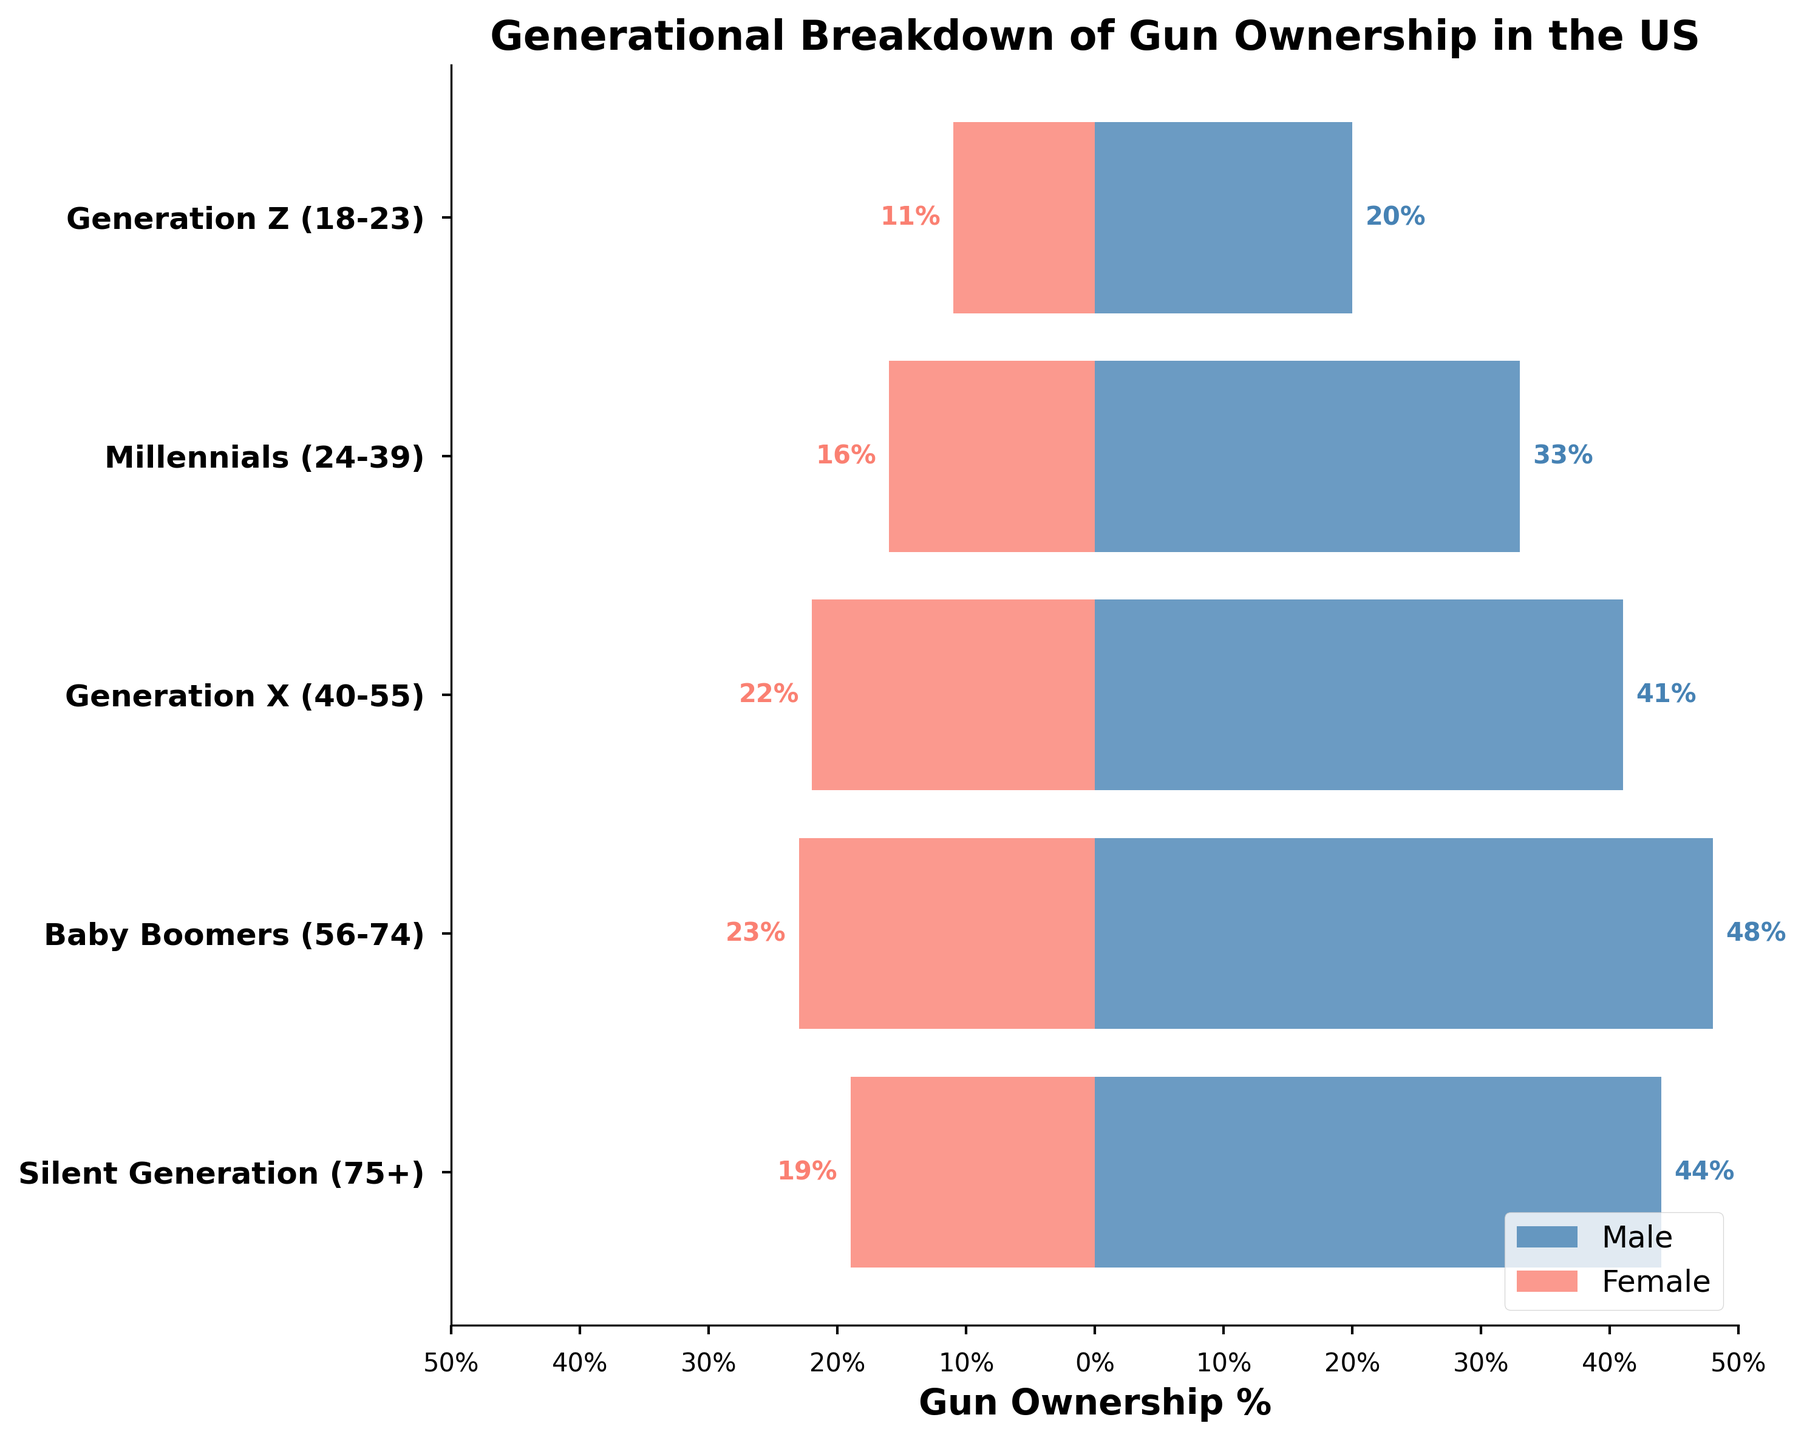What is the title of the figure? The title is located at the top of the figure and explicitly states the main topic being depicted.
Answer: Generational Breakdown of Gun Ownership in the US Which gender has the highest gun ownership percentage in the Baby Boomers group? By comparing the bar lengths in the Baby Boomers row, the bar representing males is longer than the bar representing females.
Answer: Male What is the percentage difference in gun ownership between males and females in the Silent Generation? The percentage difference is found by subtracting the female ownership percentage from the male ownership percentage for the Silent Generation: 44% - 19% = 25%.
Answer: 25% How does male gun ownership in Generation Z compare to female gun ownership in Generation X? Visual inspection shows that the bar for male ownership in Generation Z is 20%, while the bar for female ownership in Generation X is 22%. Thus, female ownership in Generation X is slightly higher.
Answer: Female ownership in Generation X is higher What age group shows the least disparity between male and female gun ownership percentages? By looking at the bars for each age group, the Millennium group has the closest percentages: 33% for males and 16% for females, a difference of 17 percentage points.
Answer: Millennials What is the average gun ownership percentage for males across all generations? The average is calculated by summing the percentages for males across all generations and then dividing by the number of generations: (44 + 48 + 41 + 33 + 20) / 5 = 37.2%.
Answer: 37.2% Which age group has the highest female gun ownership percentage? Comparing the lengths of the bars for females across all age groups, Baby Boomers have the highest percentage at 23%.
Answer: Baby Boomers How much higher is the male gun ownership percentage in Generation X compared to Generation Z? Subtract the percentage of males in Generation Z from that in Generation X: 41% - 20% = 21%.
Answer: 21% Which generation shows the lowest percentage of gun ownership for both genders combined? By inspecting both sets of bars together, Generation Z has the lowest combined percentages with 20% for males and 11% for females, totaling 31%.
Answer: Generation Z 